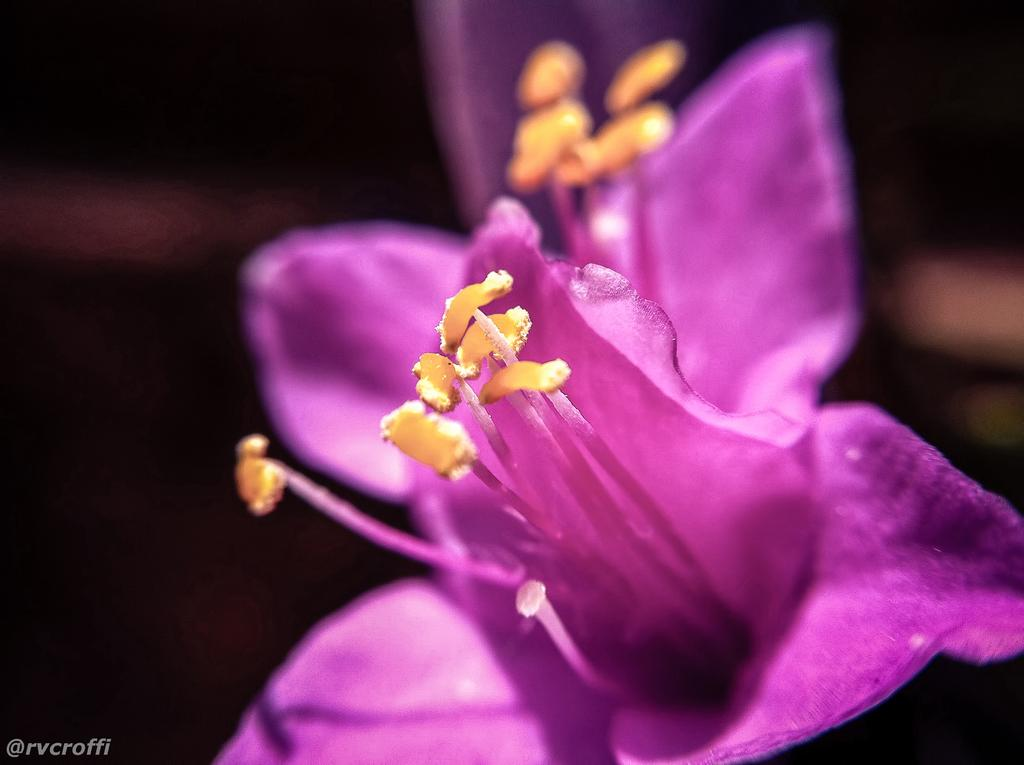What is the main subject of the image? There is a flower in the image. Can you describe the background of the image? The background of the image is dark. What type of crack can be seen in the image? There is no crack present in the image; it features a flower with a dark background. What color is the crayon used to draw the flower in the image? There is no crayon or drawing present in the image; it is a photograph of a real flower. 